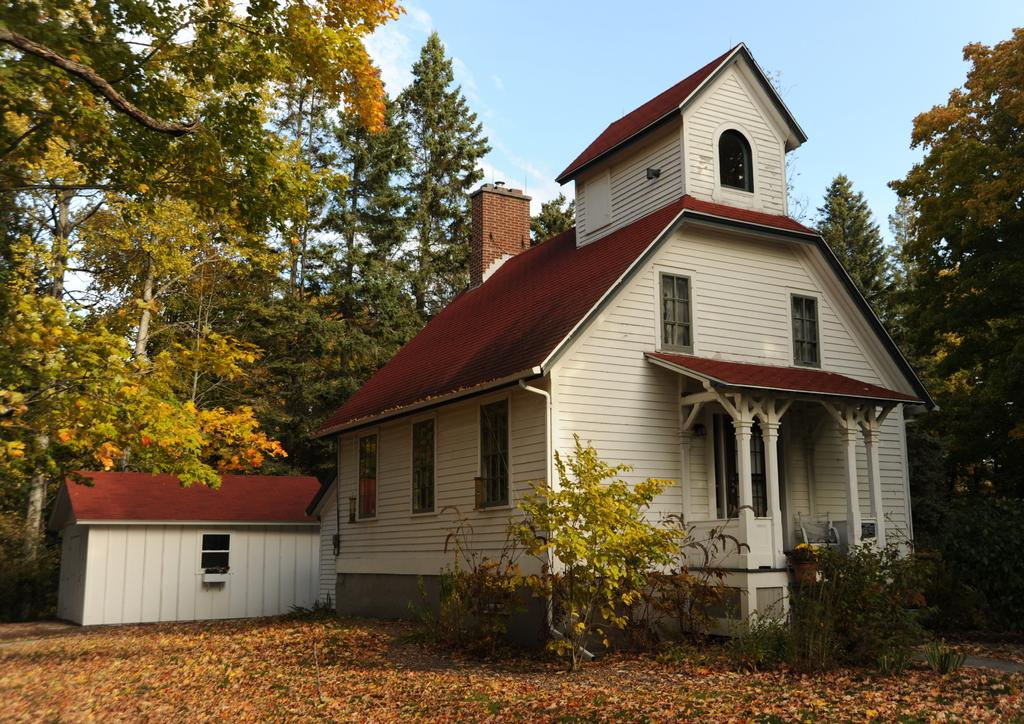What type of structures are present in the image? There are houses in the image. What are some features of the houses? The houses have walls, windows, and doors. Are there any architectural elements in the image? Yes, there are pillars in the image. What can be seen at the bottom of the image? There is a plant at the bottom of the image. What is visible in the background of the image? There are trees and the sky in the background of the image. What type of liquid is being recited in verse in the image? There is no liquid or verse present in the image; it features houses, walls, windows, doors, pillars, a plant, trees, and the sky in the background. 